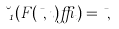<formula> <loc_0><loc_0><loc_500><loc_500>\lambda _ { 1 } ( F ( \mu , \zeta ) \delta _ { \zeta } ) = \mu ,</formula> 